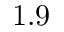Convert formula to latex. <formula><loc_0><loc_0><loc_500><loc_500>1 . 9</formula> 